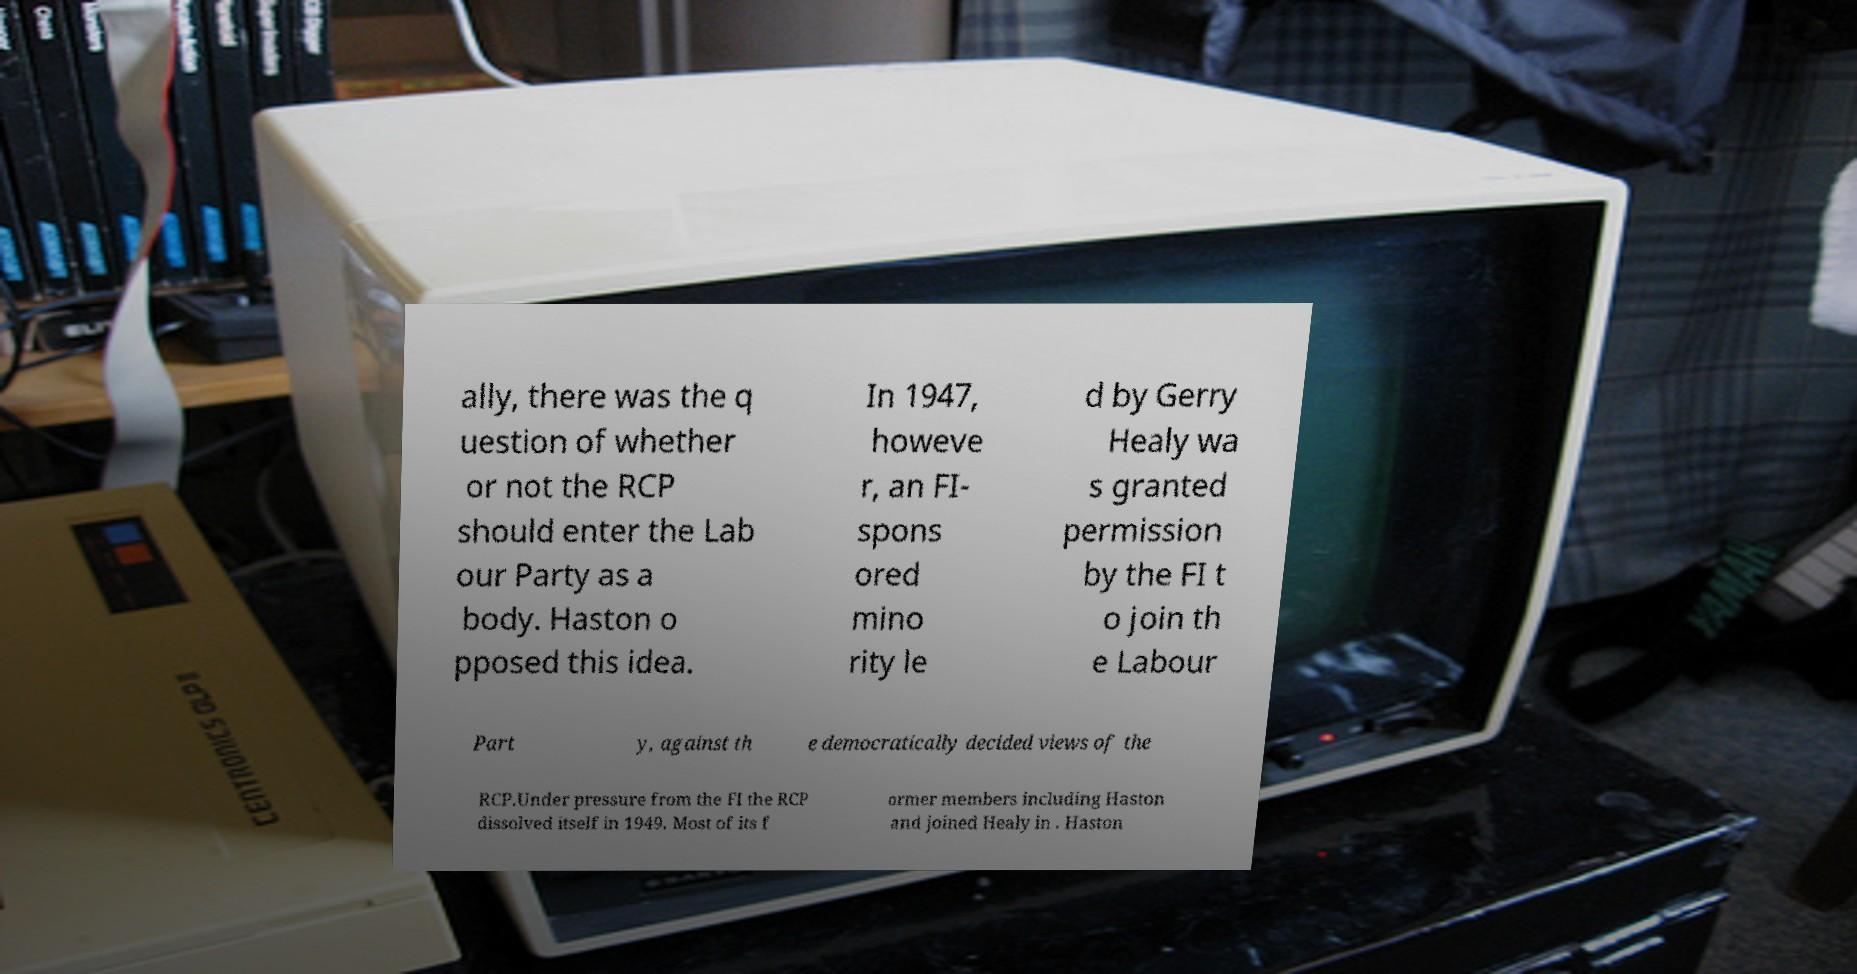Could you extract and type out the text from this image? ally, there was the q uestion of whether or not the RCP should enter the Lab our Party as a body. Haston o pposed this idea. In 1947, howeve r, an FI- spons ored mino rity le d by Gerry Healy wa s granted permission by the FI t o join th e Labour Part y, against th e democratically decided views of the RCP.Under pressure from the FI the RCP dissolved itself in 1949. Most of its f ormer members including Haston and joined Healy in . Haston 